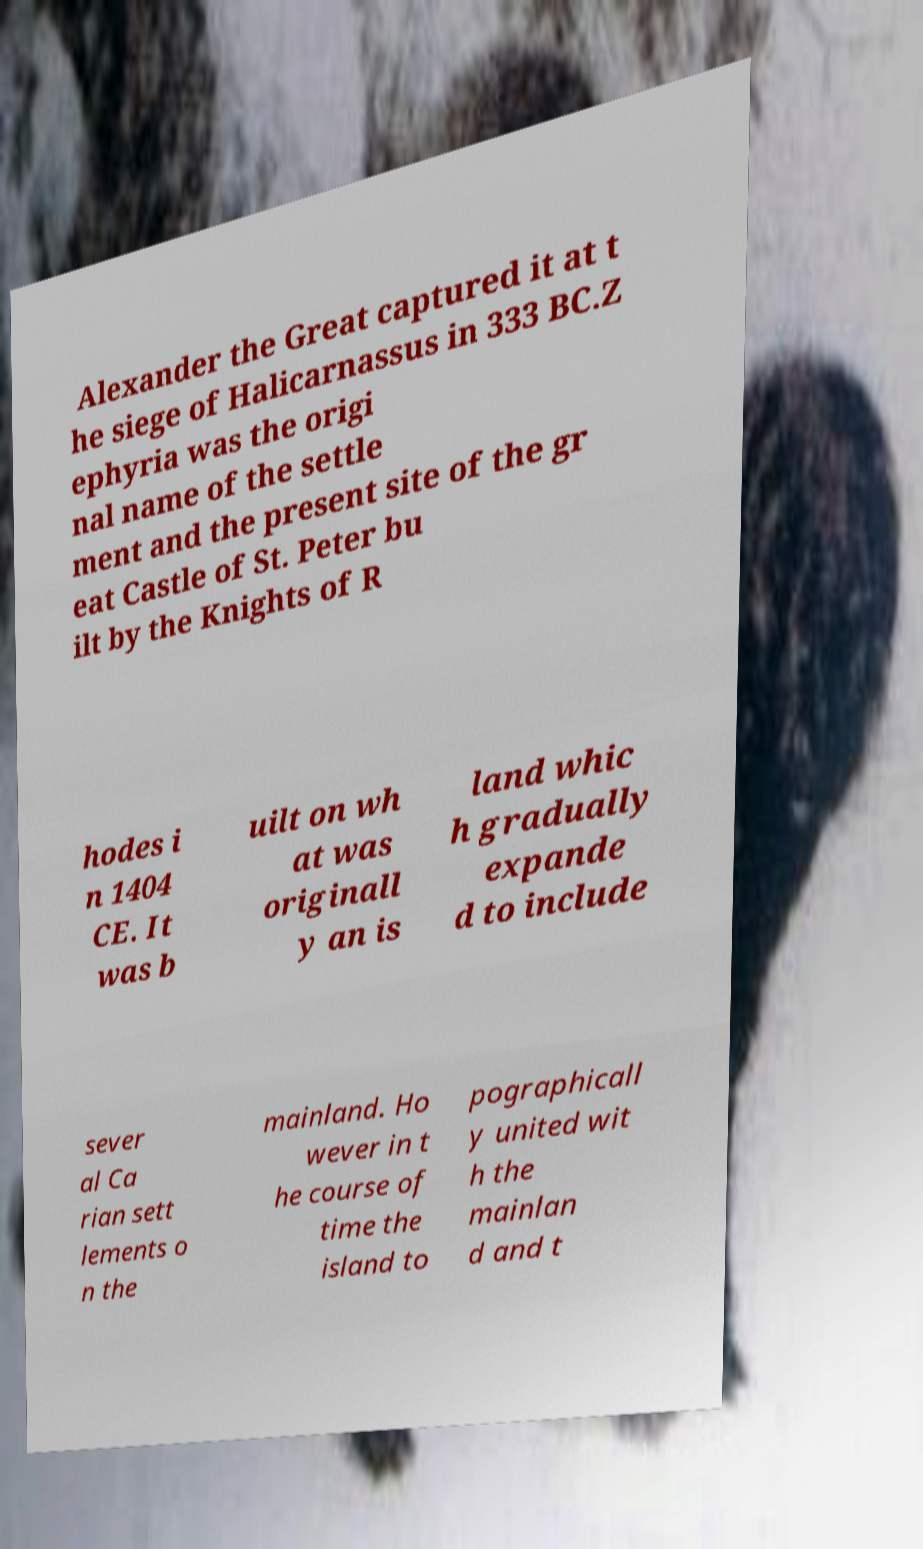Please read and relay the text visible in this image. What does it say? Alexander the Great captured it at t he siege of Halicarnassus in 333 BC.Z ephyria was the origi nal name of the settle ment and the present site of the gr eat Castle of St. Peter bu ilt by the Knights of R hodes i n 1404 CE. It was b uilt on wh at was originall y an is land whic h gradually expande d to include sever al Ca rian sett lements o n the mainland. Ho wever in t he course of time the island to pographicall y united wit h the mainlan d and t 